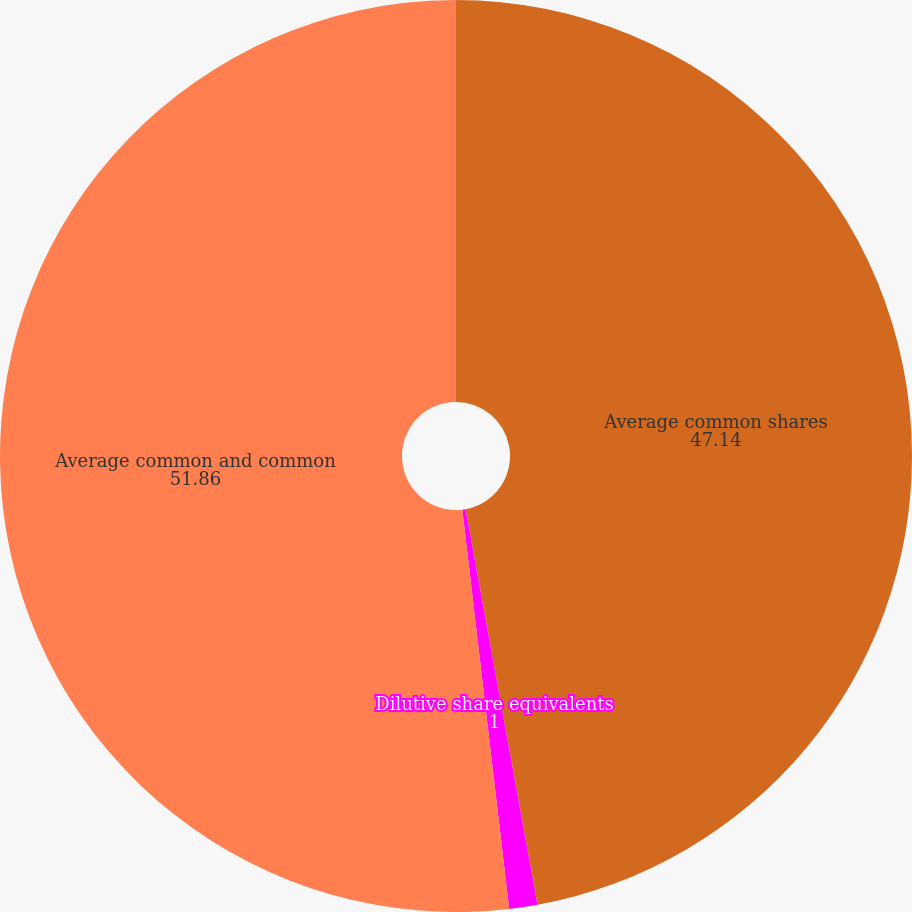Convert chart. <chart><loc_0><loc_0><loc_500><loc_500><pie_chart><fcel>Average common shares<fcel>Dilutive share equivalents<fcel>Average common and common<nl><fcel>47.14%<fcel>1.0%<fcel>51.86%<nl></chart> 